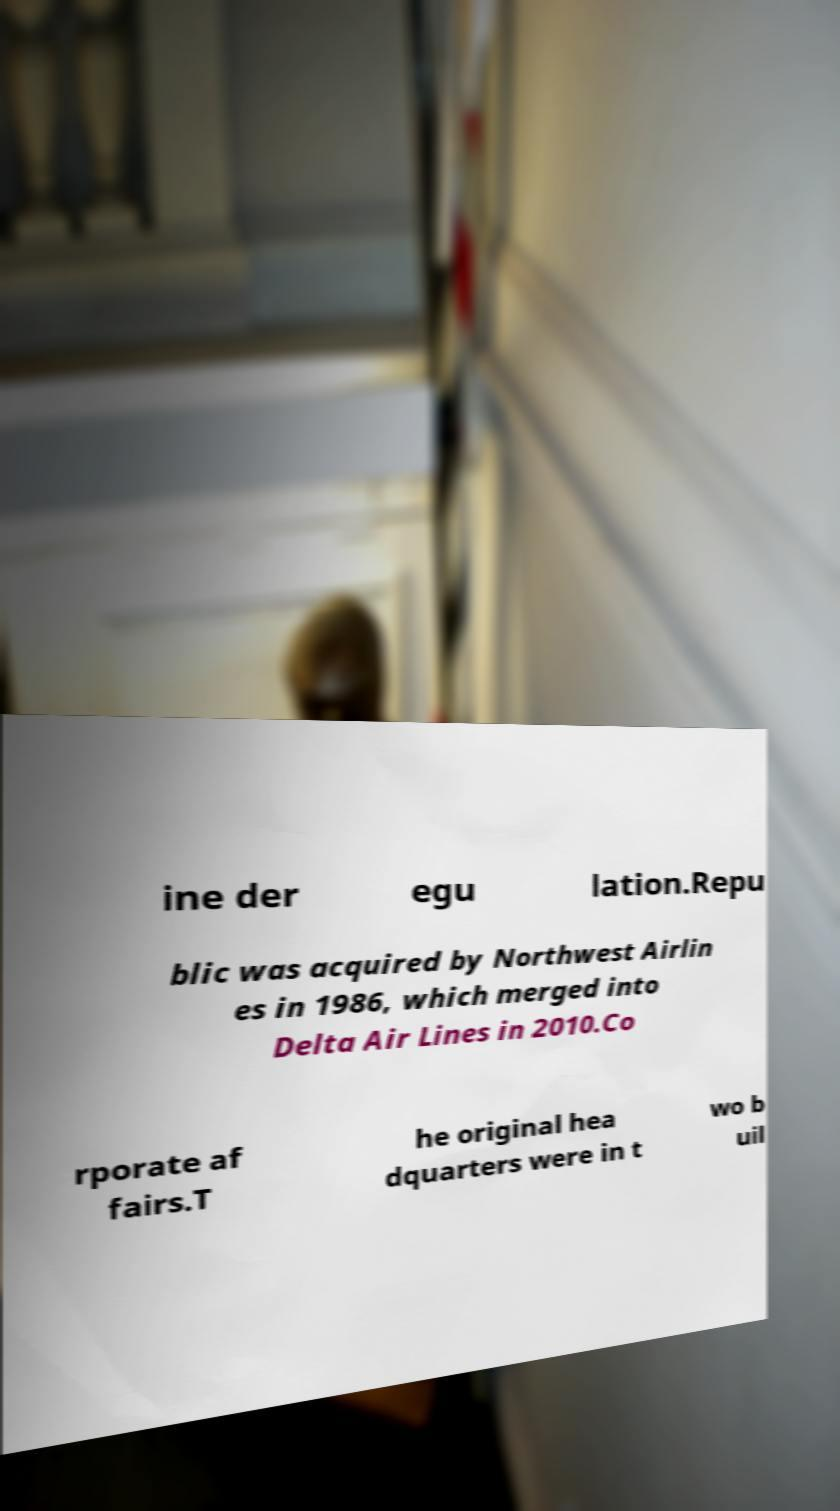What messages or text are displayed in this image? I need them in a readable, typed format. ine der egu lation.Repu blic was acquired by Northwest Airlin es in 1986, which merged into Delta Air Lines in 2010.Co rporate af fairs.T he original hea dquarters were in t wo b uil 